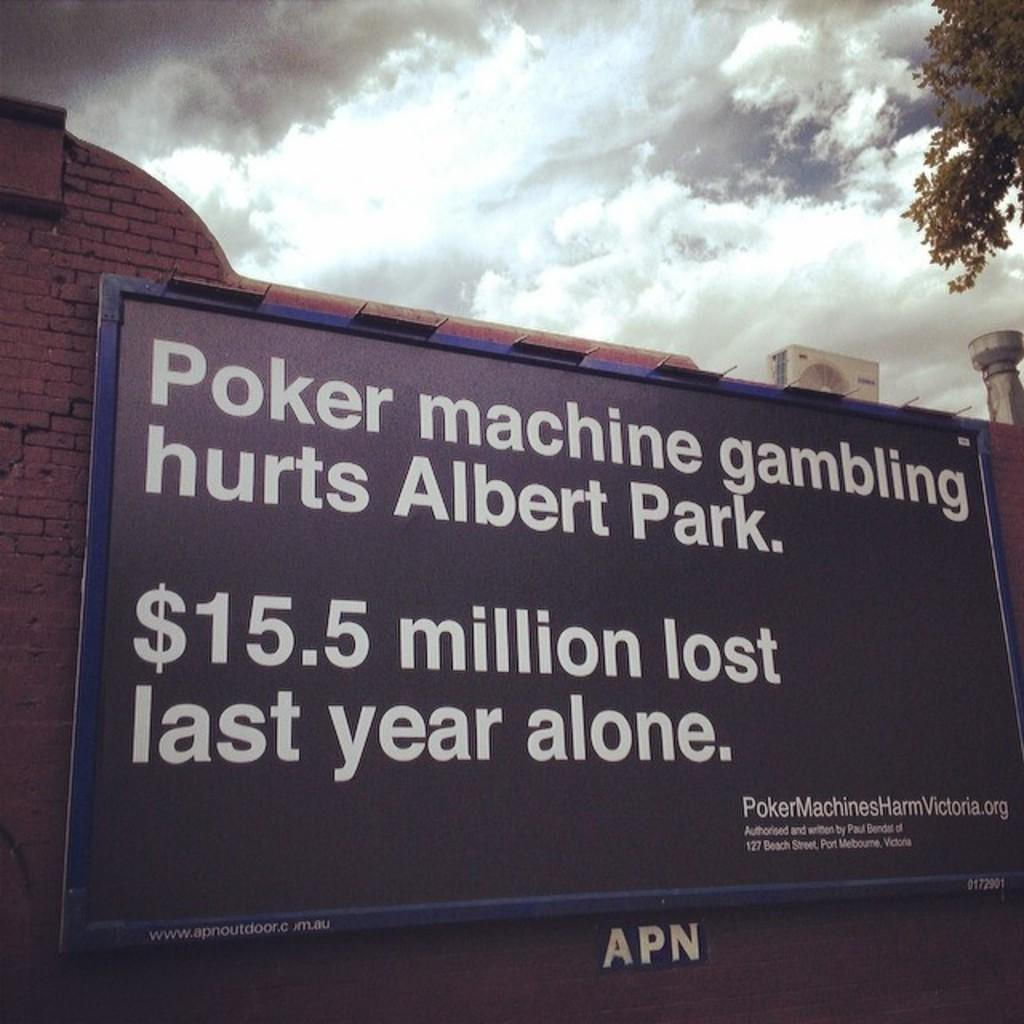<image>
Share a concise interpretation of the image provided. A large sign that says "Poker machine gambling hurts Albert Park." 